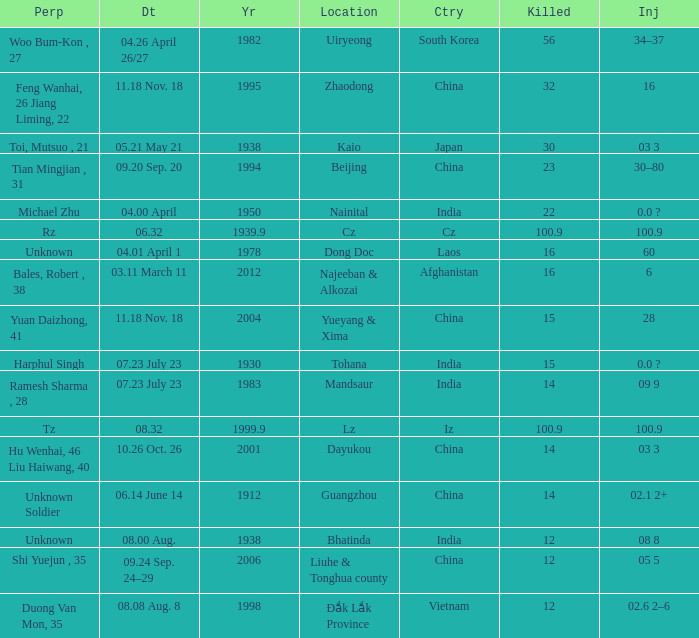9, and when "year" exceeds 193 Iz. 